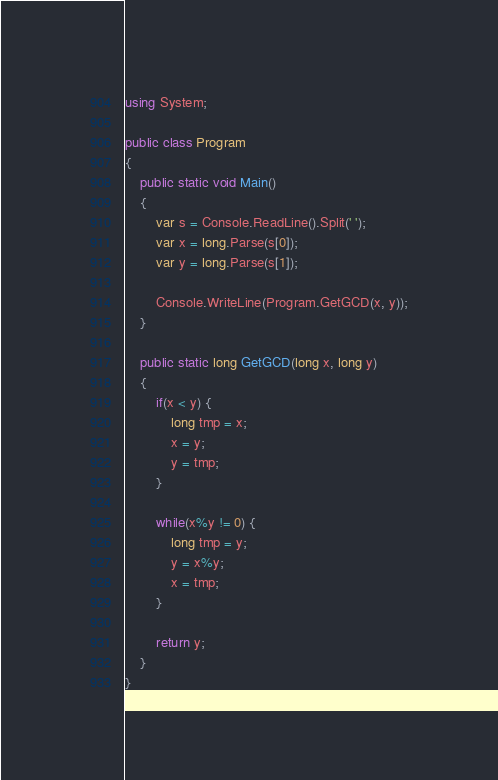<code> <loc_0><loc_0><loc_500><loc_500><_C#_>using System;

public class Program
{
	public static void Main()
	{
		var s = Console.ReadLine().Split(' ');
		var x = long.Parse(s[0]);
		var y = long.Parse(s[1]);
		
		Console.WriteLine(Program.GetGCD(x, y));
	}
	
	public static long GetGCD(long x, long y)
	{
		if(x < y) {
			long tmp = x;
			x = y;
			y = tmp;
		}
		
		while(x%y != 0) {
			long tmp = y;
			y = x%y;
			x = tmp;
		}
		
		return y;
	}
}</code> 